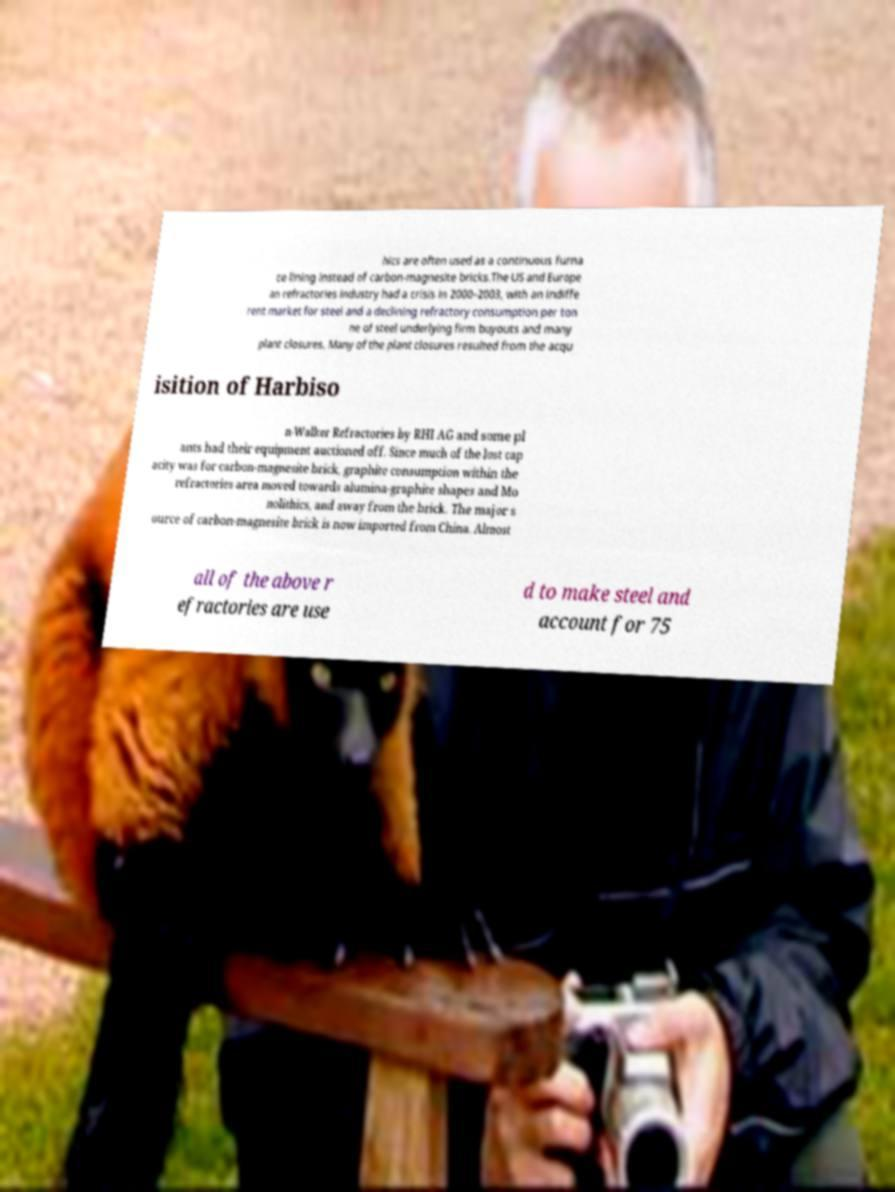Can you accurately transcribe the text from the provided image for me? hics are often used as a continuous furna ce lining instead of carbon-magnesite bricks.The US and Europe an refractories industry had a crisis in 2000–2003, with an indiffe rent market for steel and a declining refractory consumption per ton ne of steel underlying firm buyouts and many plant closures. Many of the plant closures resulted from the acqu isition of Harbiso n-Walker Refractories by RHI AG and some pl ants had their equipment auctioned off. Since much of the lost cap acity was for carbon-magnesite brick, graphite consumption within the refractories area moved towards alumina-graphite shapes and Mo nolithics, and away from the brick. The major s ource of carbon-magnesite brick is now imported from China. Almost all of the above r efractories are use d to make steel and account for 75 